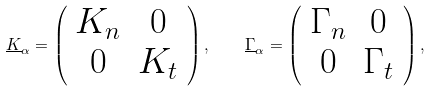Convert formula to latex. <formula><loc_0><loc_0><loc_500><loc_500>\underline { K } _ { \alpha } = \left ( \begin{array} { c c } K _ { n } & 0 \\ 0 & K _ { t } \end{array} \right ) , \quad \underline { \Gamma } _ { \alpha } = \left ( \begin{array} { c c } \Gamma _ { n } & 0 \\ 0 & \Gamma _ { t } \end{array} \right ) ,</formula> 